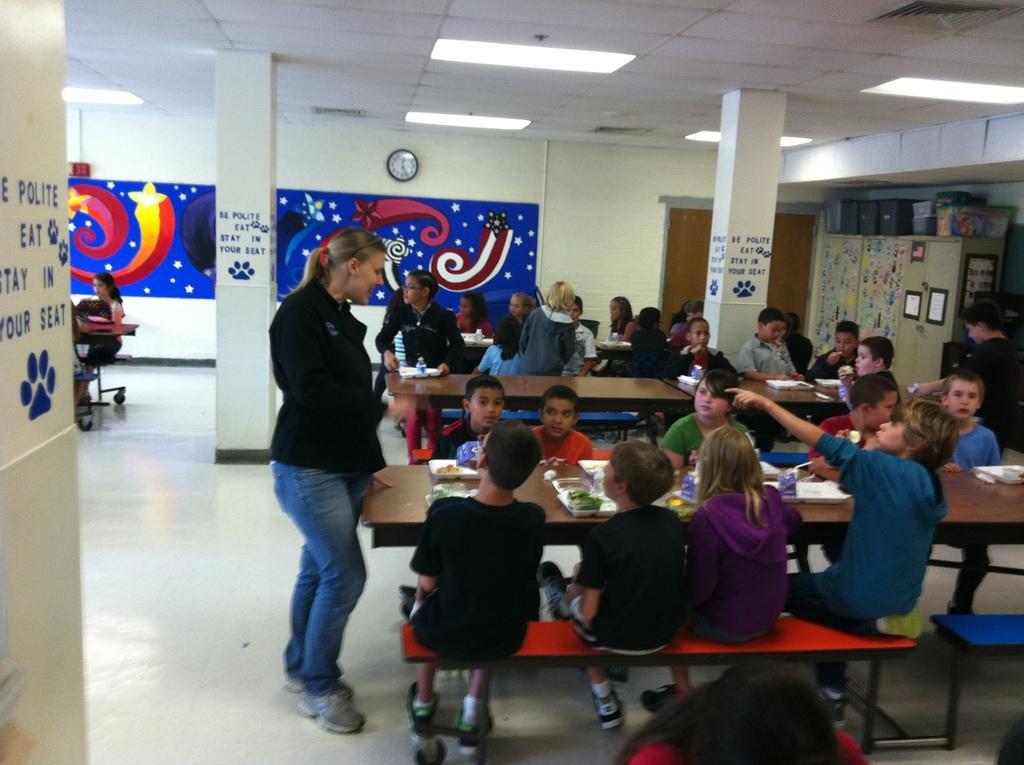Could you give a brief overview of what you see in this image? In this picture we can see a few people sitting on the benches. We can see a woman standing on the floor. There are some food items visible on the plates. We can see a few bottles, bags and other objects on the tables. There is some text on the pillars. We can see some painting and a clock on the wall. We can see a few objects on the right side. There is a wooden object. Some lights are visible on top. 